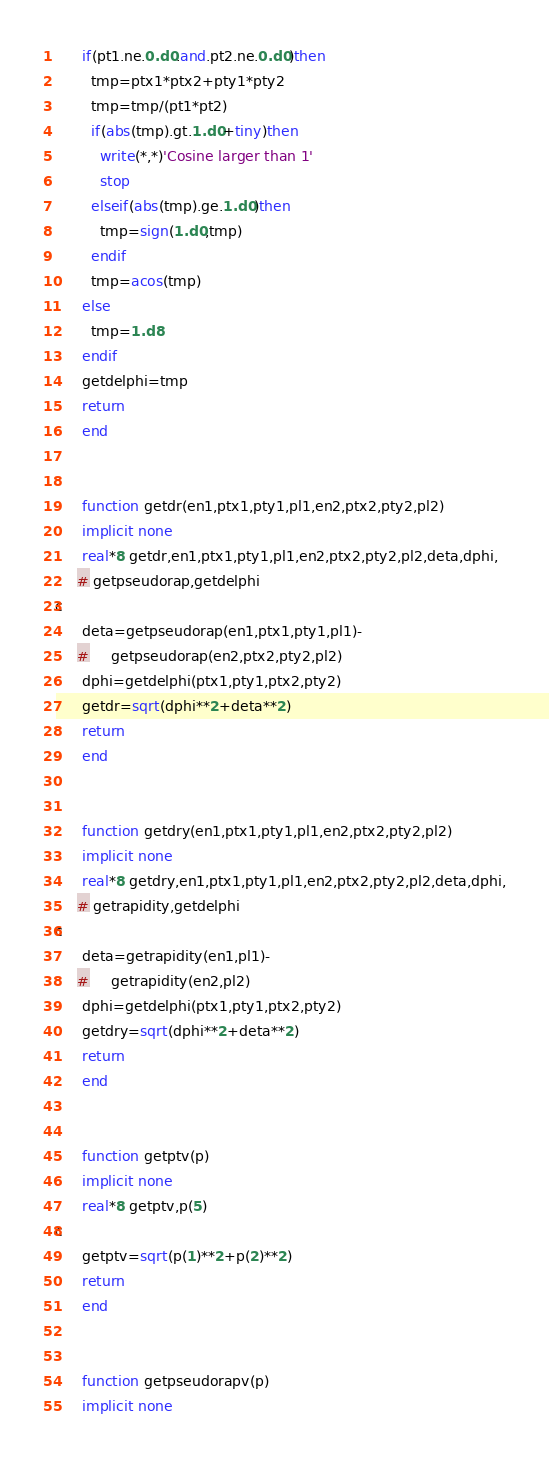Convert code to text. <code><loc_0><loc_0><loc_500><loc_500><_FORTRAN_>      if(pt1.ne.0.d0.and.pt2.ne.0.d0)then
        tmp=ptx1*ptx2+pty1*pty2
        tmp=tmp/(pt1*pt2)
        if(abs(tmp).gt.1.d0+tiny)then
          write(*,*)'Cosine larger than 1'
          stop
        elseif(abs(tmp).ge.1.d0)then
          tmp=sign(1.d0,tmp)
        endif
        tmp=acos(tmp)
      else
        tmp=1.d8
      endif
      getdelphi=tmp
      return
      end


      function getdr(en1,ptx1,pty1,pl1,en2,ptx2,pty2,pl2)
      implicit none
      real*8 getdr,en1,ptx1,pty1,pl1,en2,ptx2,pty2,pl2,deta,dphi,
     # getpseudorap,getdelphi
c
      deta=getpseudorap(en1,ptx1,pty1,pl1)-
     #     getpseudorap(en2,ptx2,pty2,pl2)
      dphi=getdelphi(ptx1,pty1,ptx2,pty2)
      getdr=sqrt(dphi**2+deta**2)
      return
      end


      function getdry(en1,ptx1,pty1,pl1,en2,ptx2,pty2,pl2)
      implicit none
      real*8 getdry,en1,ptx1,pty1,pl1,en2,ptx2,pty2,pl2,deta,dphi,
     # getrapidity,getdelphi
c
      deta=getrapidity(en1,pl1)-
     #     getrapidity(en2,pl2)
      dphi=getdelphi(ptx1,pty1,ptx2,pty2)
      getdry=sqrt(dphi**2+deta**2)
      return
      end


      function getptv(p)
      implicit none
      real*8 getptv,p(5)
c
      getptv=sqrt(p(1)**2+p(2)**2)
      return
      end


      function getpseudorapv(p)
      implicit none</code> 